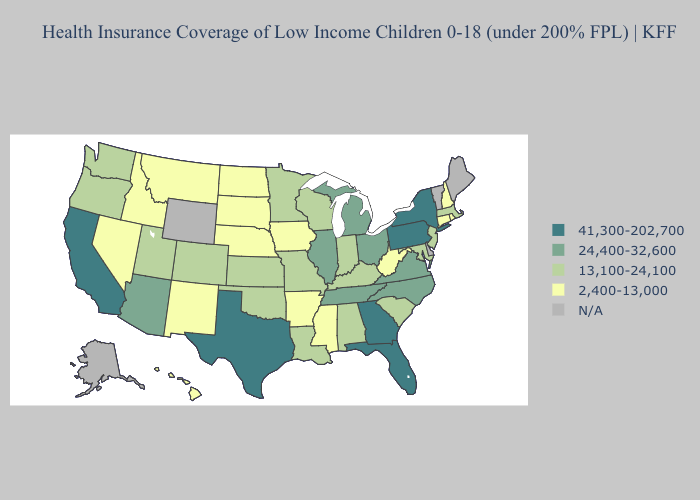What is the value of Mississippi?
Keep it brief. 2,400-13,000. What is the lowest value in states that border North Dakota?
Keep it brief. 2,400-13,000. What is the highest value in the South ?
Be succinct. 41,300-202,700. What is the lowest value in states that border Louisiana?
Quick response, please. 2,400-13,000. What is the value of Maine?
Quick response, please. N/A. Name the states that have a value in the range N/A?
Quick response, please. Alaska, Delaware, Maine, Vermont, Wyoming. What is the value of Alabama?
Short answer required. 13,100-24,100. What is the highest value in the USA?
Be succinct. 41,300-202,700. What is the value of Michigan?
Quick response, please. 24,400-32,600. Name the states that have a value in the range 41,300-202,700?
Give a very brief answer. California, Florida, Georgia, New York, Pennsylvania, Texas. Does Iowa have the lowest value in the MidWest?
Quick response, please. Yes. Name the states that have a value in the range 13,100-24,100?
Write a very short answer. Alabama, Colorado, Indiana, Kansas, Kentucky, Louisiana, Maryland, Massachusetts, Minnesota, Missouri, New Jersey, Oklahoma, Oregon, South Carolina, Utah, Washington, Wisconsin. What is the value of Iowa?
Keep it brief. 2,400-13,000. What is the value of Nevada?
Concise answer only. 2,400-13,000. 